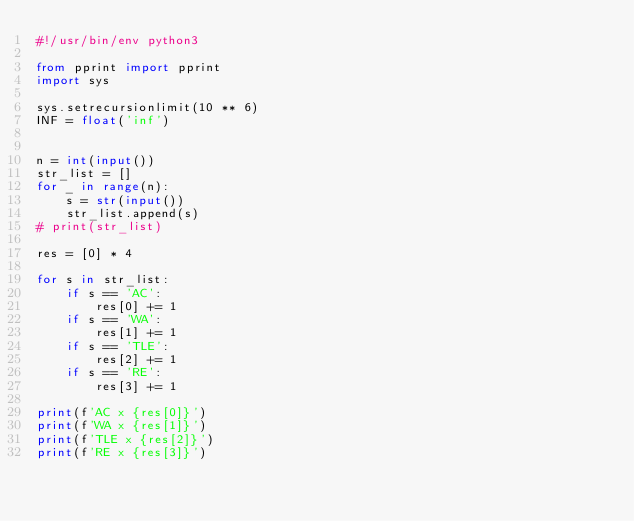Convert code to text. <code><loc_0><loc_0><loc_500><loc_500><_Python_>#!/usr/bin/env python3

from pprint import pprint
import sys

sys.setrecursionlimit(10 ** 6)
INF = float('inf')


n = int(input())
str_list = []
for _ in range(n):
    s = str(input())
    str_list.append(s)
# print(str_list)

res = [0] * 4

for s in str_list:
    if s == 'AC':
        res[0] += 1
    if s == 'WA':
        res[1] += 1
    if s == 'TLE':
        res[2] += 1
    if s == 'RE':
        res[3] += 1

print(f'AC x {res[0]}')
print(f'WA x {res[1]}')
print(f'TLE x {res[2]}')
print(f'RE x {res[3]}')
</code> 